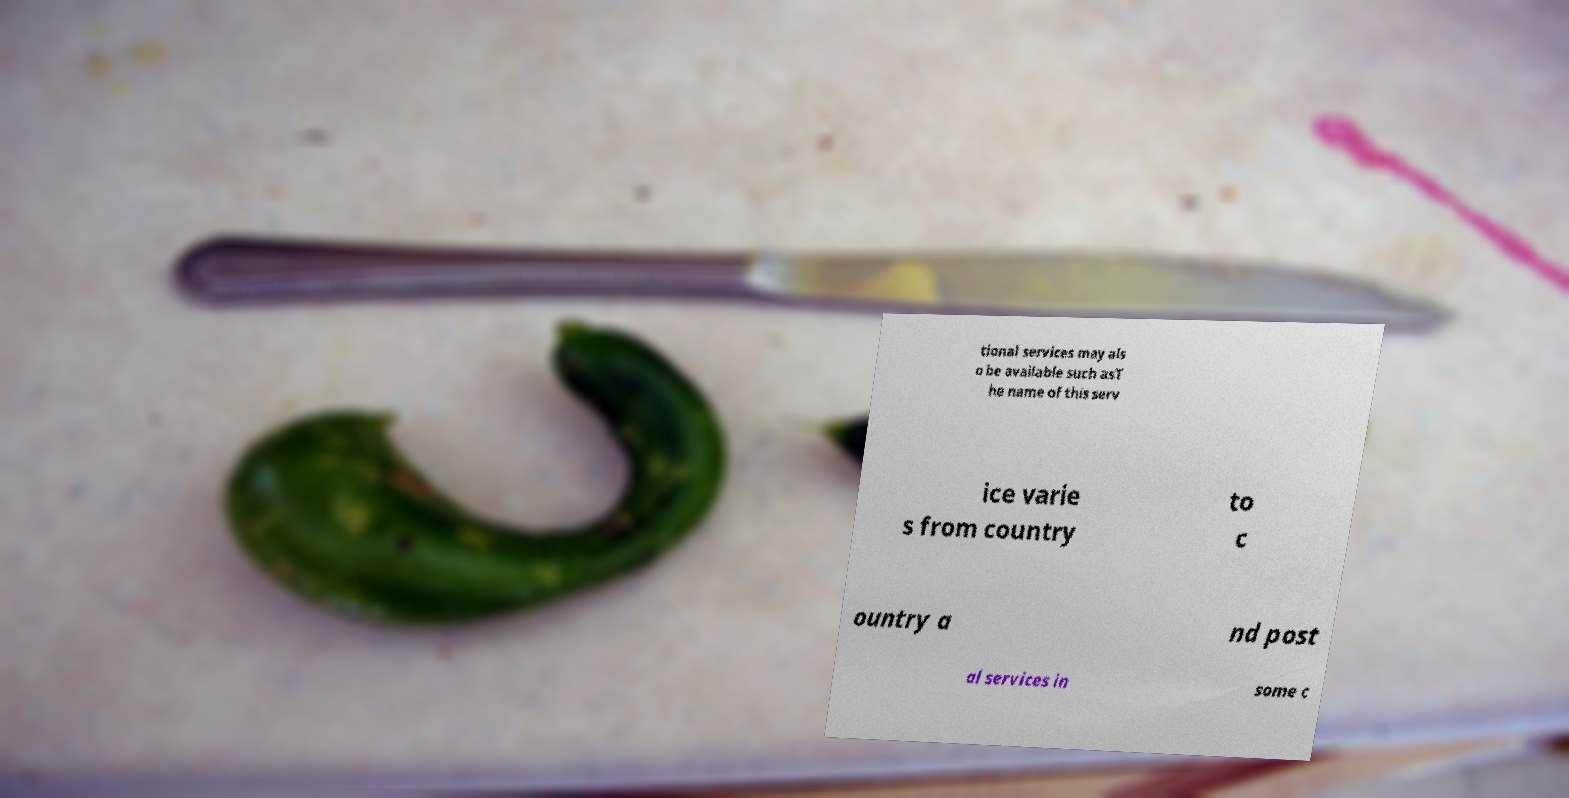What messages or text are displayed in this image? I need them in a readable, typed format. tional services may als o be available such asT he name of this serv ice varie s from country to c ountry a nd post al services in some c 